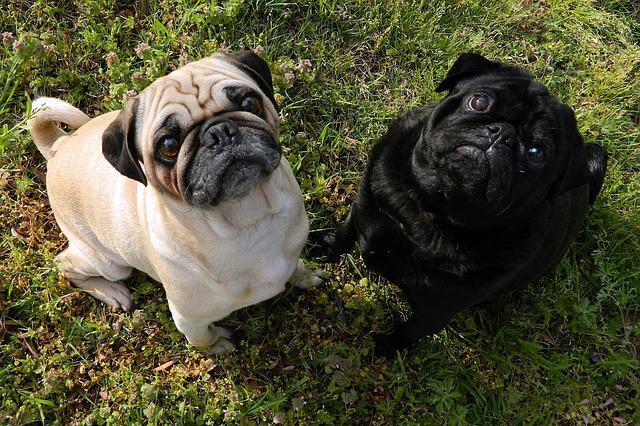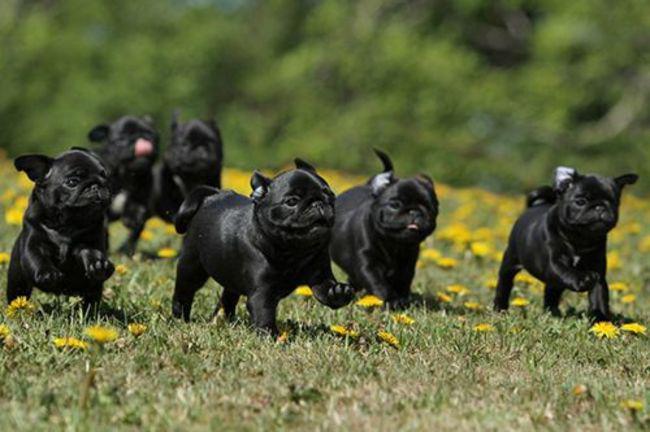The first image is the image on the left, the second image is the image on the right. For the images shown, is this caption "There are two dogs in the image on the left." true? Answer yes or no. Yes. 